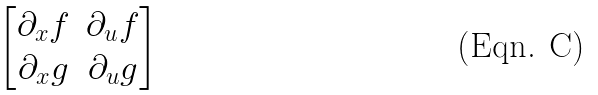Convert formula to latex. <formula><loc_0><loc_0><loc_500><loc_500>\begin{bmatrix} \partial _ { x } f & \partial _ { u } f \\ \partial _ { x } g & \partial _ { u } g \end{bmatrix}</formula> 